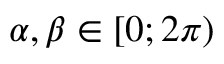Convert formula to latex. <formula><loc_0><loc_0><loc_500><loc_500>\alpha , \beta \in [ 0 ; 2 \pi )</formula> 